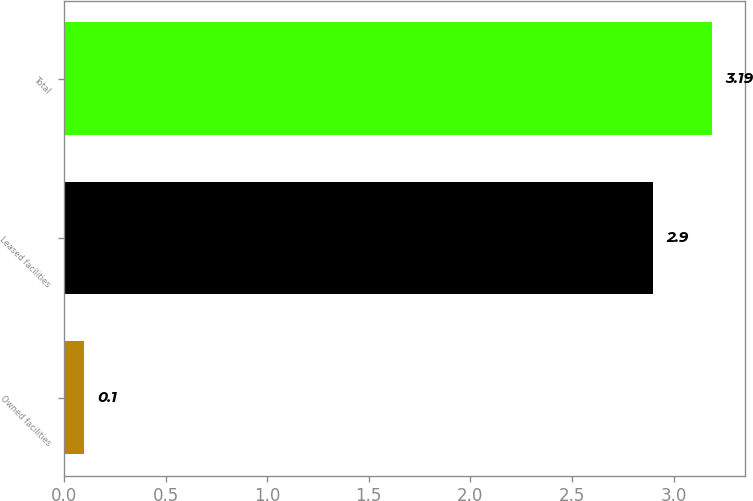Convert chart to OTSL. <chart><loc_0><loc_0><loc_500><loc_500><bar_chart><fcel>Owned facilities<fcel>Leased facilities<fcel>Total<nl><fcel>0.1<fcel>2.9<fcel>3.19<nl></chart> 